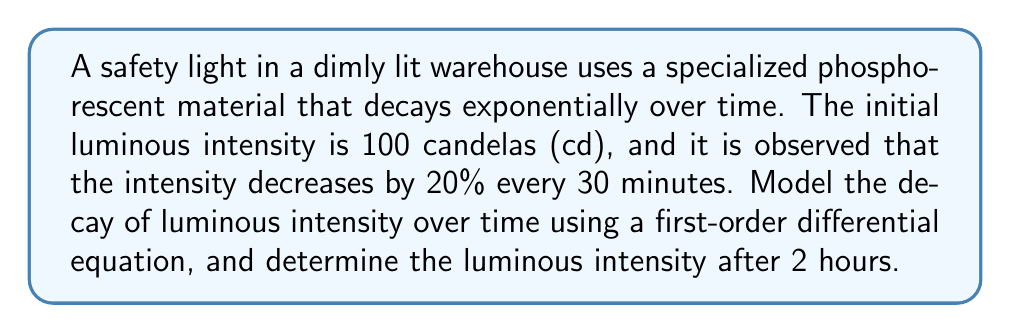Can you solve this math problem? Let's approach this problem step-by-step:

1) Let $I(t)$ be the luminous intensity at time $t$ (in hours).

2) The decay rate is exponential, so we can model this with the differential equation:

   $$\frac{dI}{dt} = -kI$$

   where $k$ is the decay constant.

3) We know that $I(0) = 100$ cd (initial intensity).

4) To find $k$, we can use the given information that the intensity decreases by 20% every 30 minutes:

   $$I(0.5) = 100 \cdot 0.8 = 80$$

5) The solution to the differential equation is:

   $$I(t) = I(0)e^{-kt}$$

6) Substituting the known values:

   $$80 = 100e^{-k(0.5)}$$

7) Solving for $k$:

   $$0.8 = e^{-0.5k}$$
   $$\ln(0.8) = -0.5k$$
   $$k = -\frac{2\ln(0.8)}{1} \approx 0.4463$$

8) Now we have our complete model:

   $$I(t) = 100e^{-0.4463t}$$

9) To find the intensity after 2 hours, we substitute $t=2$:

   $$I(2) = 100e^{-0.4463(2)} \approx 41.11$$

Therefore, after 2 hours, the luminous intensity will be approximately 41.11 candelas.
Answer: The luminous intensity after 2 hours will be approximately 41.11 candelas. 